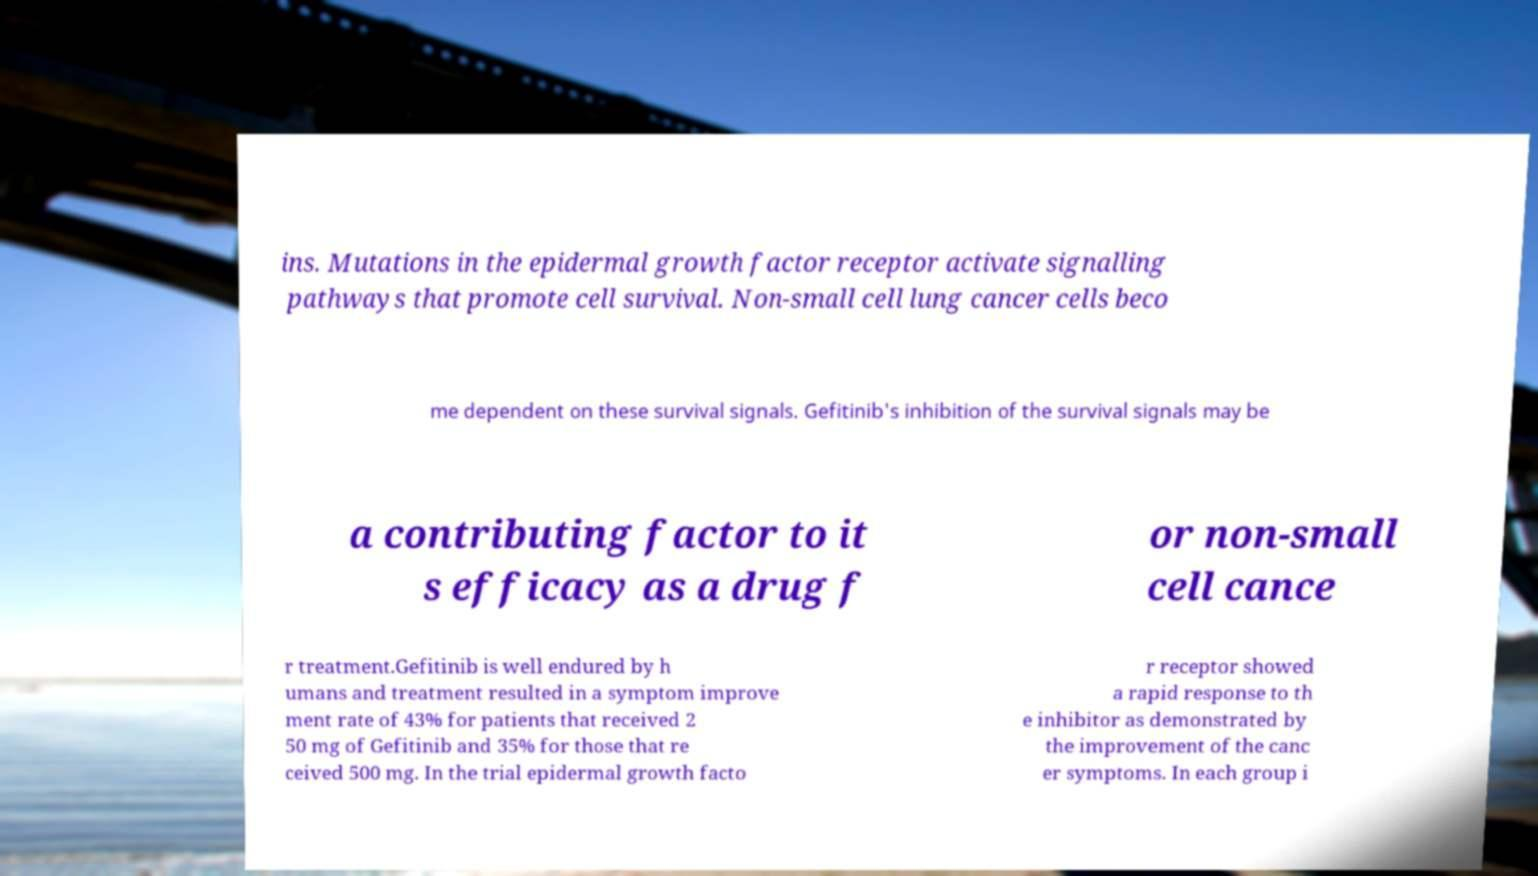There's text embedded in this image that I need extracted. Can you transcribe it verbatim? ins. Mutations in the epidermal growth factor receptor activate signalling pathways that promote cell survival. Non-small cell lung cancer cells beco me dependent on these survival signals. Gefitinib's inhibition of the survival signals may be a contributing factor to it s efficacy as a drug f or non-small cell cance r treatment.Gefitinib is well endured by h umans and treatment resulted in a symptom improve ment rate of 43% for patients that received 2 50 mg of Gefitinib and 35% for those that re ceived 500 mg. In the trial epidermal growth facto r receptor showed a rapid response to th e inhibitor as demonstrated by the improvement of the canc er symptoms. In each group i 